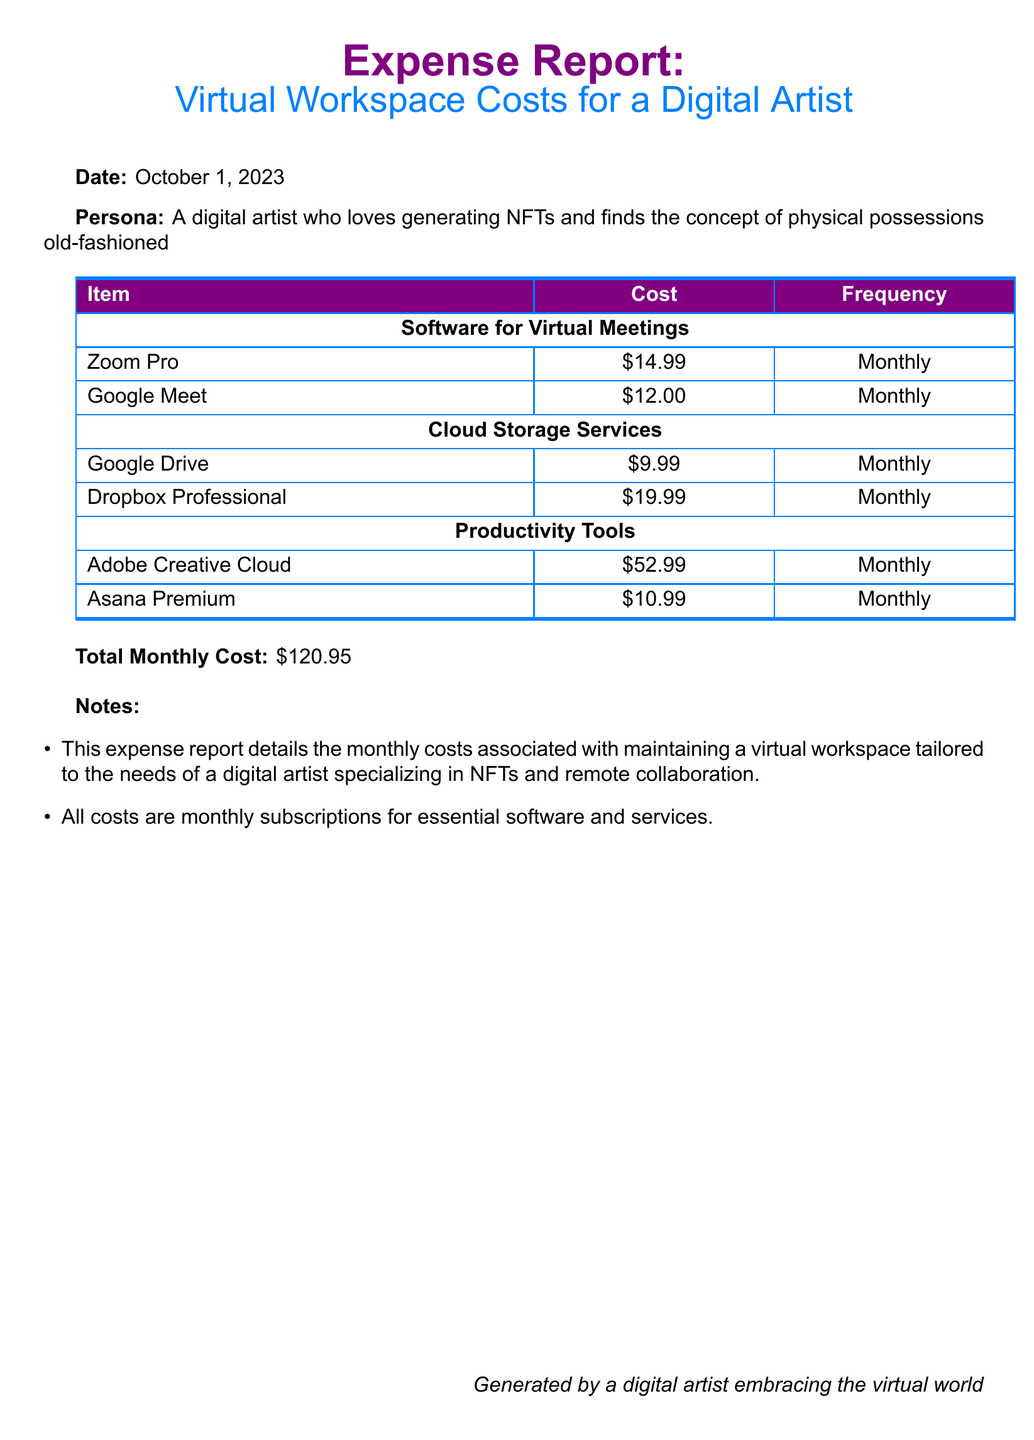What is the total monthly cost? The total monthly cost is explicitly mentioned in the document as the sum of all expenses.
Answer: \$120.95 How many software services are listed for virtual meetings? The document lists two software services for virtual meetings, which are Zoom Pro and Google Meet.
Answer: 2 What is the cost of Adobe Creative Cloud? Adobe Creative Cloud's cost is specified in the expenses section of the document.
Answer: \$52.99 What frequency is stated for Google Drive? The frequency for Google Drive is indicated in the document as a monthly subscription.
Answer: Monthly What color is used for the report title? The color used for the report title in the document is described under the color definitions.
Answer: nftpurple Which productivity tool is the least expensive? The document provides the costs for productivity tools, and Asana Premium is listed with the lowest cost.
Answer: \$10.99 How many categories of expenses are detailed? The document specifies three categories of expenses: Software for Virtual Meetings, Cloud Storage Services, and Productivity Tools.
Answer: 3 Is there a note about the nature of the expenses? The notes section contains information regarding the purpose of the reported expenses, indicating they are monthly subscriptions essential for a digital artist.
Answer: Yes 